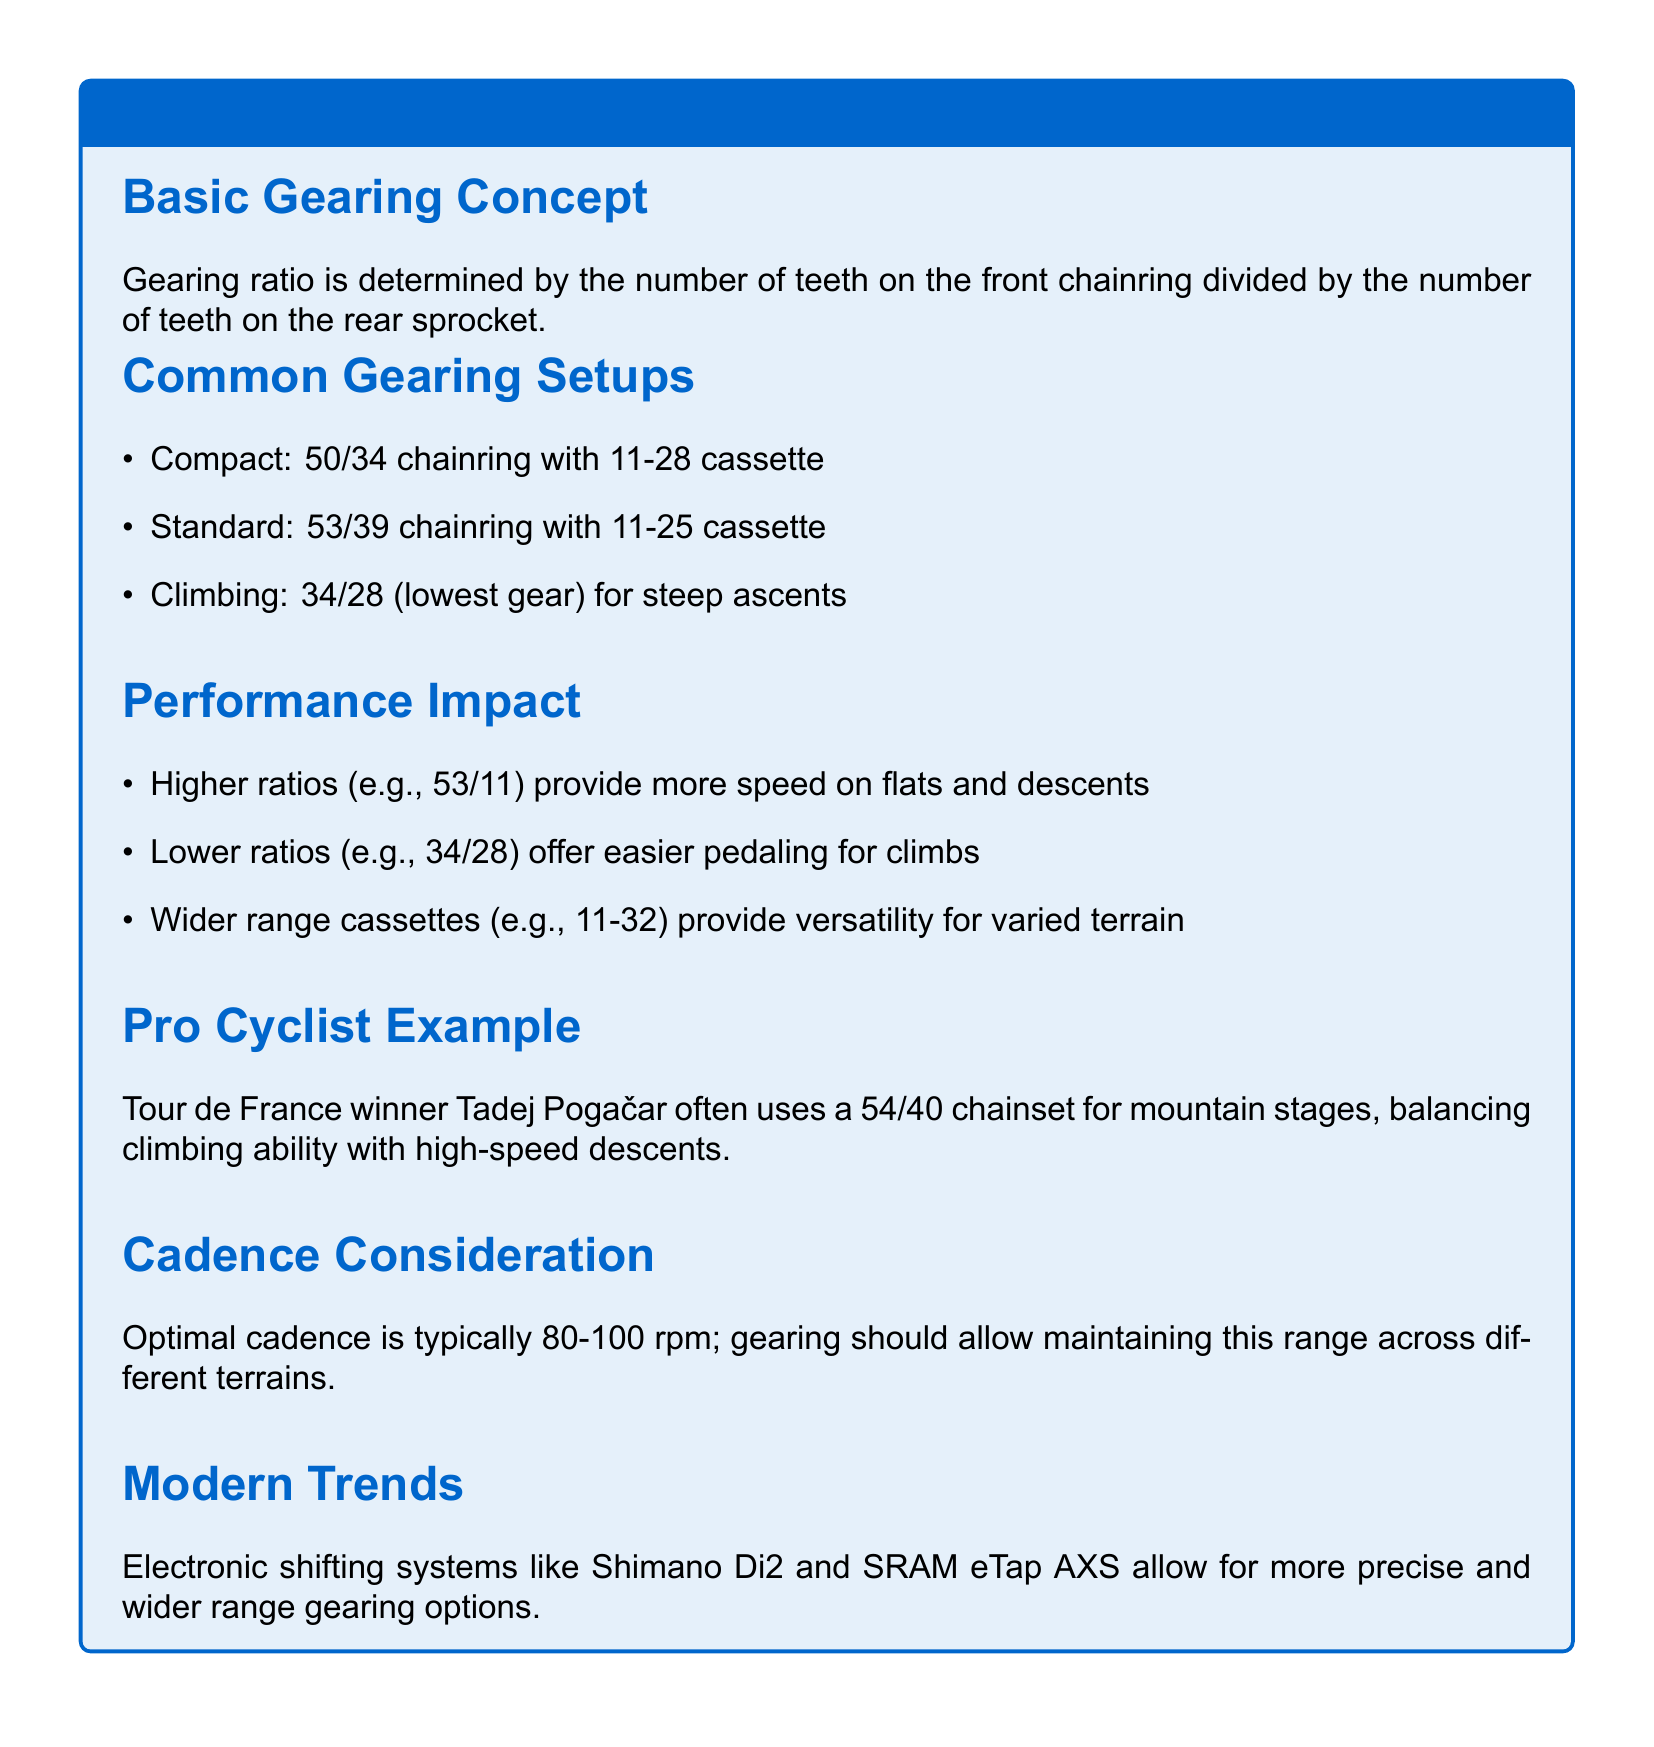What is the gear ratio determined by? The gear ratio is determined by the number of teeth on the front chainring divided by the number of teeth on the rear sprocket.
Answer: Number of teeth What is a common compact gearing setup? A common compact gearing setup is specified in the document as a chainring and cassette configuration.
Answer: 50/34 chainring with 11-28 cassette What does a higher gear ratio provide? A higher gear ratio provides more speed on flats and descents as stated in the performance impact section.
Answer: More speed What chainset does Tadej Pogačar often use? The document mentions Tadej Pogačar's specific chainset for mountain stages to illustrate a pro cyclist's choice.
Answer: 54/40 chainset What is the optimal cadence range? The optimal cadence is mentioned in the document, indicating a preferred cycling rhythm.
Answer: 80-100 rpm What advantage do wider range cassettes provide? The document explains the versatility provided by wider range cassettes, allowing riders to adapt to different environments.
Answer: Versatility for varied terrain What modern trend is mentioned in the document? The document highlights a specific technology trend affecting bicycle gearing systems.
Answer: Electronic shifting systems What is the purpose of a climbing gearing setup? The document describes the specific gear configuration aimed at facilitating climbing.
Answer: Easier pedaling for climbs 